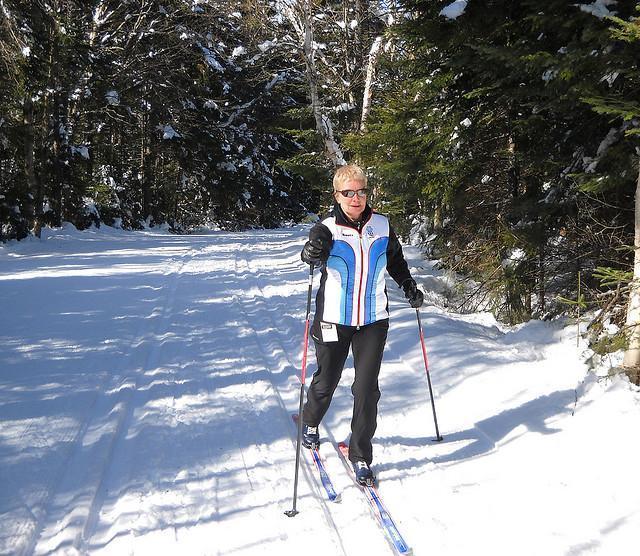How many horses are eating?
Give a very brief answer. 0. 